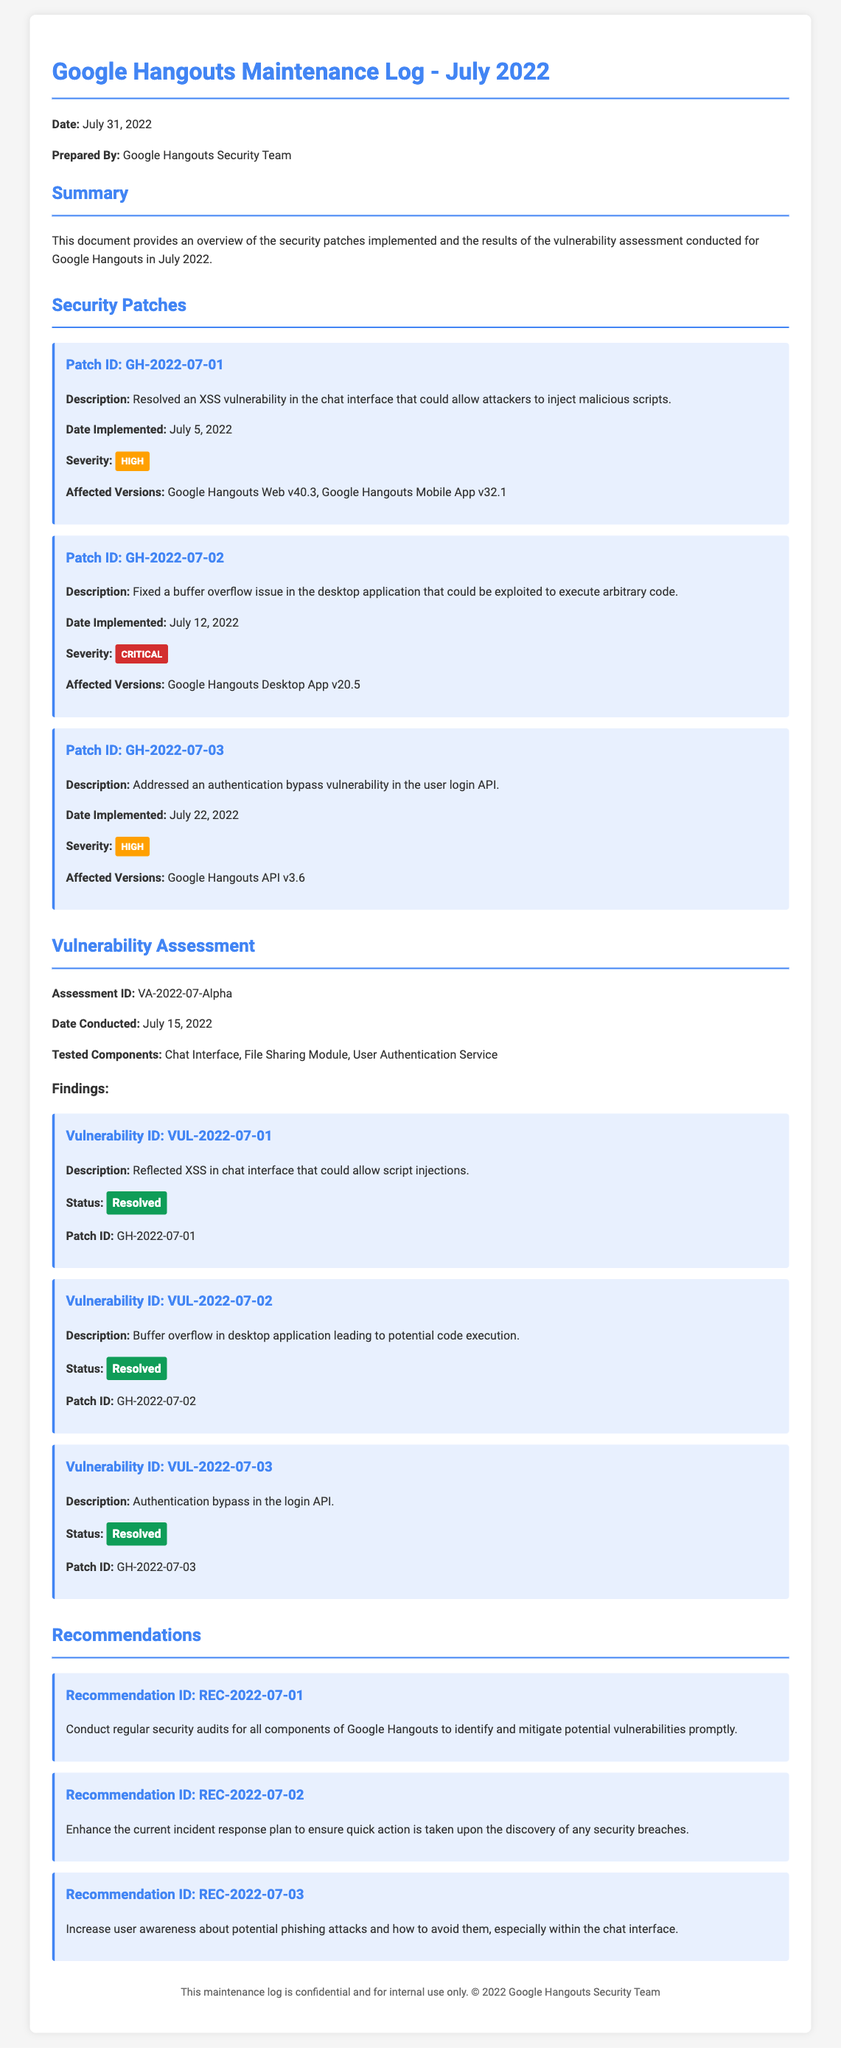What is the date of the maintenance log? The maintenance log is dated July 31, 2022.
Answer: July 31, 2022 Who prepared the maintenance log? The maintenance log was prepared by the Google Hangouts Security Team.
Answer: Google Hangouts Security Team What is the severity of Patch ID GH-2022-07-02? Patch ID GH-2022-07-02 has a severity level classified as Critical.
Answer: Critical When was the buffer overflow issue patched? The buffer overflow issue was fixed on July 12, 2022.
Answer: July 12, 2022 How many vulnerabilities were found during the assessment? Three vulnerabilities were identified and addressed based on the findings.
Answer: Three What is one of the recommendations made in the maintenance log? One recommendation is to conduct regular security audits for all components.
Answer: Conduct regular security audits What was the assessment ID for the vulnerability assessment? The assessment ID for the vulnerability assessment is VA-2022-07-Alpha.
Answer: VA-2022-07-Alpha What is the status of vulnerability ID VUL-2022-07-03? The status of vulnerability ID VUL-2022-07-03 is Resolved.
Answer: Resolved What was the date of the vulnerability assessment? The vulnerability assessment was conducted on July 15, 2022.
Answer: July 15, 2022 